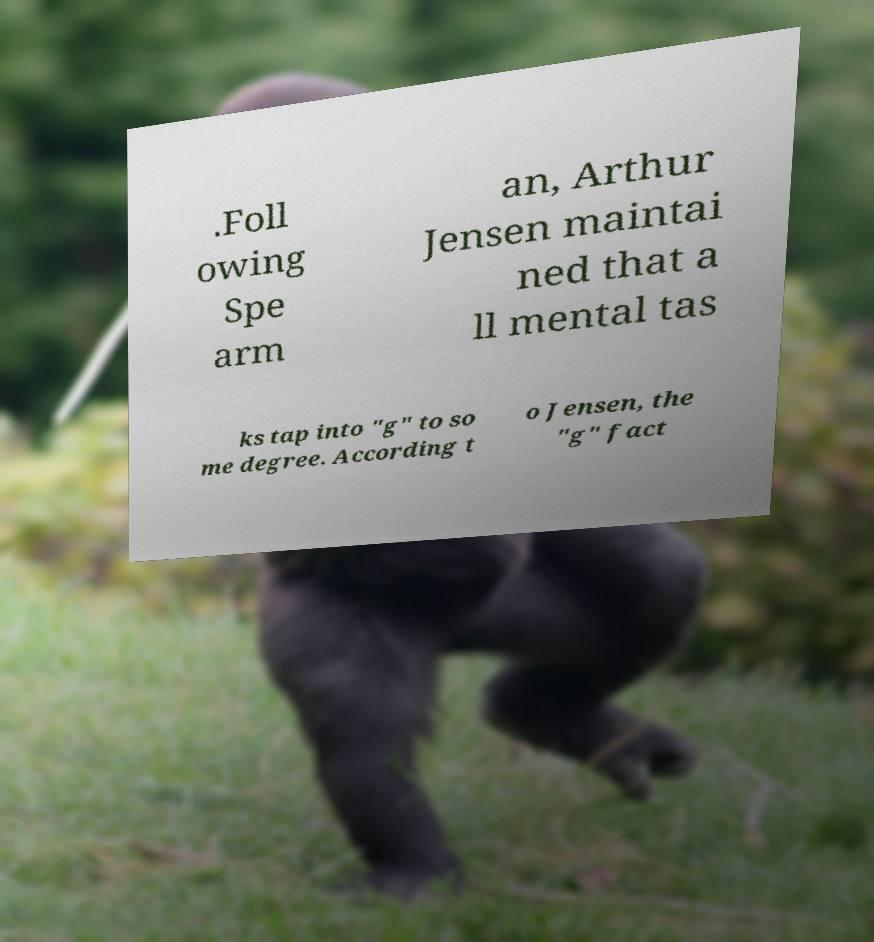Could you extract and type out the text from this image? .Foll owing Spe arm an, Arthur Jensen maintai ned that a ll mental tas ks tap into "g" to so me degree. According t o Jensen, the "g" fact 